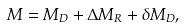Convert formula to latex. <formula><loc_0><loc_0><loc_500><loc_500>M = M _ { D } + \Delta M _ { R } + \delta M _ { D } ,</formula> 